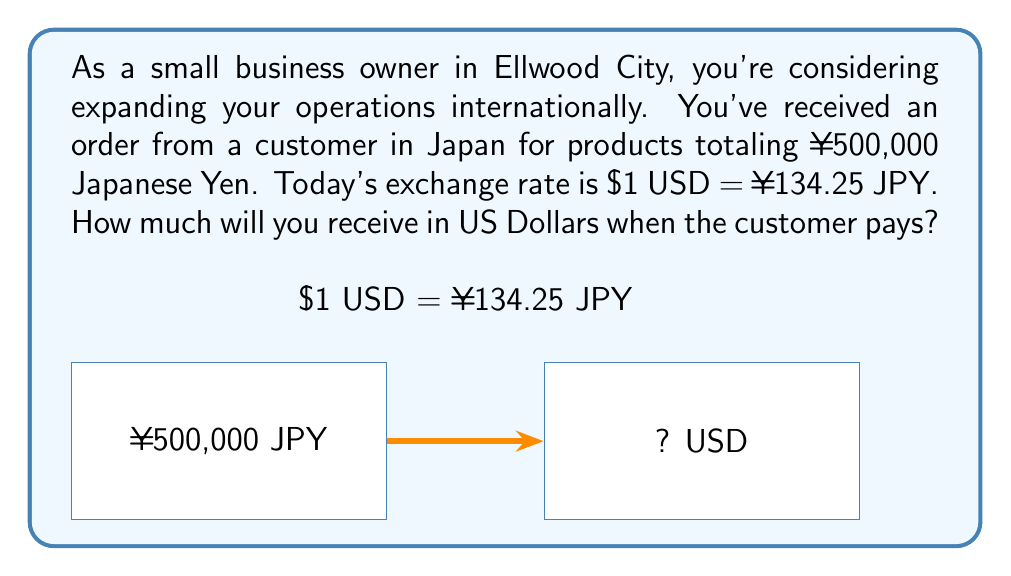What is the answer to this math problem? To solve this problem, we need to convert Japanese Yen (JPY) to US Dollars (USD). We'll use the given exchange rate:

$1 USD = ¥134.25 JPY

Step 1: Set up the conversion ratio
Let x be the amount in USD we're looking for.
$$\frac{x \text{ USD}}{500,000 \text{ JPY}} = \frac{1 \text{ USD}}{134.25 \text{ JPY}}$$

Step 2: Cross multiply
$$(x)(134.25) = (1)(500,000)$$

Step 3: Solve for x
$$x = \frac{500,000}{134.25}$$

Step 4: Calculate the result
$$x = 3724.9441 \text{ USD}$$

Step 5: Round to two decimal places (standard for currency)
$$x \approx 3724.94 \text{ USD}$$

Therefore, when the customer pays ¥500,000 JPY, you will receive $3,724.94 USD.
Answer: $3,724.94 USD 